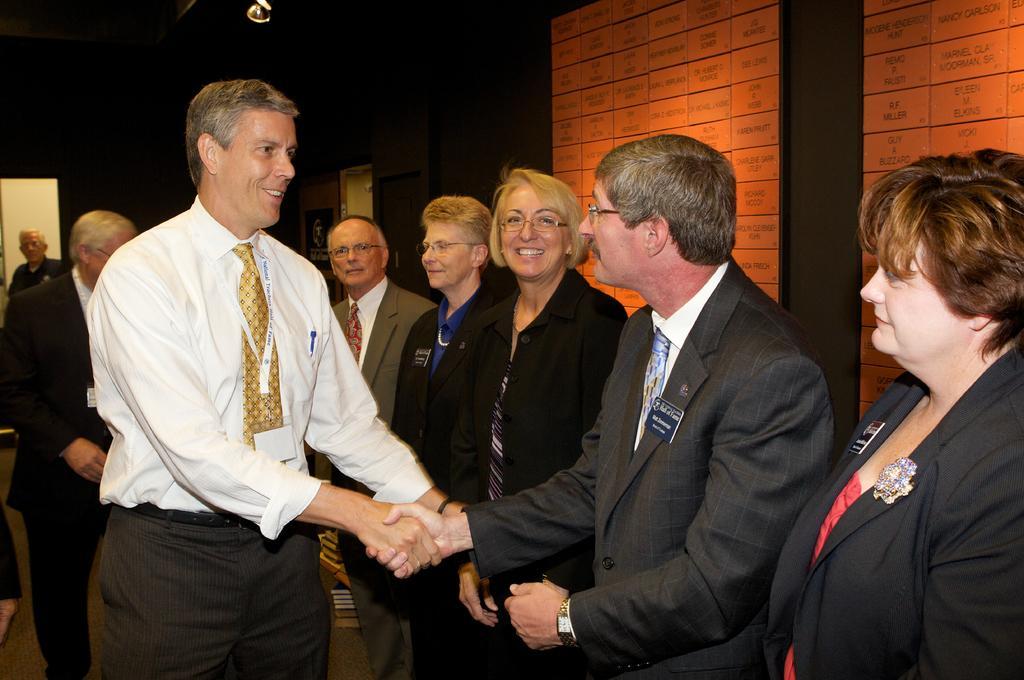Describe this image in one or two sentences. In this image, we can see some standing and two people shaking hands, in the background we can see the wall. 